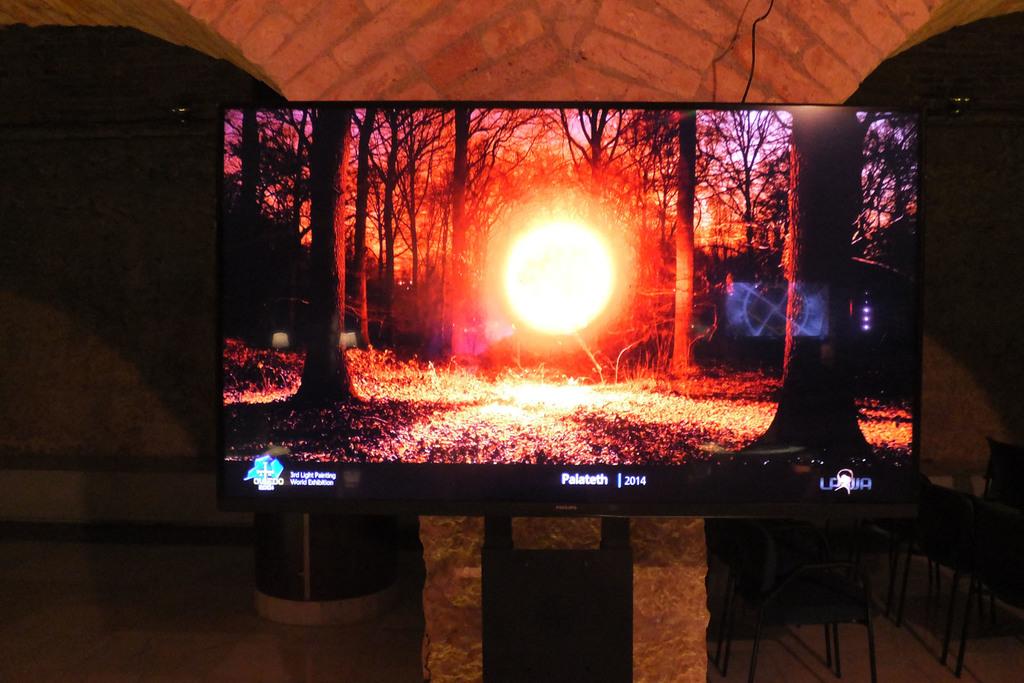What year is on the screen?
Provide a short and direct response. 2014. 